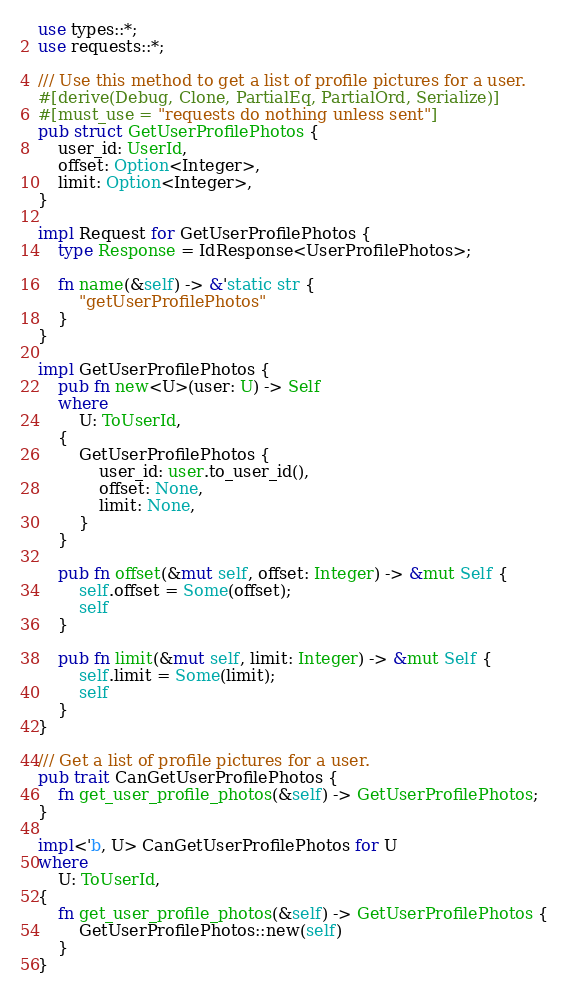<code> <loc_0><loc_0><loc_500><loc_500><_Rust_>use types::*;
use requests::*;

/// Use this method to get a list of profile pictures for a user.
#[derive(Debug, Clone, PartialEq, PartialOrd, Serialize)]
#[must_use = "requests do nothing unless sent"]
pub struct GetUserProfilePhotos {
    user_id: UserId,
    offset: Option<Integer>,
    limit: Option<Integer>,
}

impl Request for GetUserProfilePhotos {
    type Response = IdResponse<UserProfilePhotos>;

    fn name(&self) -> &'static str {
        "getUserProfilePhotos"
    }
}

impl GetUserProfilePhotos {
    pub fn new<U>(user: U) -> Self
    where
        U: ToUserId,
    {
        GetUserProfilePhotos {
            user_id: user.to_user_id(),
            offset: None,
            limit: None,
        }
    }

    pub fn offset(&mut self, offset: Integer) -> &mut Self {
        self.offset = Some(offset);
        self
    }

    pub fn limit(&mut self, limit: Integer) -> &mut Self {
        self.limit = Some(limit);
        self
    }
}

/// Get a list of profile pictures for a user.
pub trait CanGetUserProfilePhotos {
    fn get_user_profile_photos(&self) -> GetUserProfilePhotos;
}

impl<'b, U> CanGetUserProfilePhotos for U
where
    U: ToUserId,
{
    fn get_user_profile_photos(&self) -> GetUserProfilePhotos {
        GetUserProfilePhotos::new(self)
    }
}
</code> 